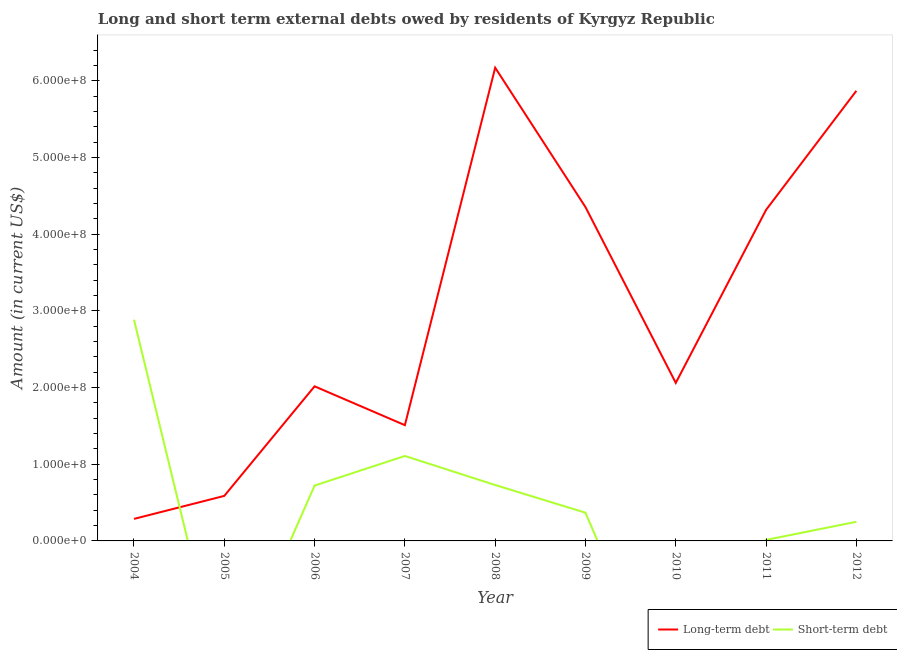Is the number of lines equal to the number of legend labels?
Make the answer very short. No. What is the long-term debts owed by residents in 2010?
Provide a succinct answer. 2.06e+08. Across all years, what is the maximum short-term debts owed by residents?
Give a very brief answer. 2.89e+08. Across all years, what is the minimum long-term debts owed by residents?
Offer a very short reply. 2.87e+07. What is the total long-term debts owed by residents in the graph?
Keep it short and to the point. 2.72e+09. What is the difference between the long-term debts owed by residents in 2008 and that in 2009?
Make the answer very short. 1.82e+08. What is the difference between the short-term debts owed by residents in 2011 and the long-term debts owed by residents in 2005?
Your answer should be compact. -5.74e+07. What is the average short-term debts owed by residents per year?
Keep it short and to the point. 6.75e+07. In the year 2009, what is the difference between the short-term debts owed by residents and long-term debts owed by residents?
Your answer should be compact. -3.99e+08. What is the ratio of the long-term debts owed by residents in 2004 to that in 2006?
Your answer should be compact. 0.14. Is the difference between the long-term debts owed by residents in 2006 and 2008 greater than the difference between the short-term debts owed by residents in 2006 and 2008?
Offer a terse response. No. What is the difference between the highest and the second highest long-term debts owed by residents?
Your answer should be compact. 3.01e+07. What is the difference between the highest and the lowest short-term debts owed by residents?
Keep it short and to the point. 2.89e+08. Is the sum of the long-term debts owed by residents in 2008 and 2012 greater than the maximum short-term debts owed by residents across all years?
Provide a succinct answer. Yes. Does the short-term debts owed by residents monotonically increase over the years?
Provide a short and direct response. No. How many lines are there?
Keep it short and to the point. 2. Are the values on the major ticks of Y-axis written in scientific E-notation?
Keep it short and to the point. Yes. Does the graph contain any zero values?
Make the answer very short. Yes. How many legend labels are there?
Offer a very short reply. 2. How are the legend labels stacked?
Keep it short and to the point. Horizontal. What is the title of the graph?
Ensure brevity in your answer.  Long and short term external debts owed by residents of Kyrgyz Republic. What is the Amount (in current US$) of Long-term debt in 2004?
Your response must be concise. 2.87e+07. What is the Amount (in current US$) in Short-term debt in 2004?
Your answer should be compact. 2.89e+08. What is the Amount (in current US$) in Long-term debt in 2005?
Keep it short and to the point. 5.87e+07. What is the Amount (in current US$) in Short-term debt in 2005?
Make the answer very short. 0. What is the Amount (in current US$) in Long-term debt in 2006?
Ensure brevity in your answer.  2.02e+08. What is the Amount (in current US$) of Short-term debt in 2006?
Your answer should be compact. 7.22e+07. What is the Amount (in current US$) of Long-term debt in 2007?
Your answer should be very brief. 1.51e+08. What is the Amount (in current US$) of Short-term debt in 2007?
Offer a terse response. 1.11e+08. What is the Amount (in current US$) of Long-term debt in 2008?
Provide a succinct answer. 6.17e+08. What is the Amount (in current US$) of Short-term debt in 2008?
Your answer should be compact. 7.29e+07. What is the Amount (in current US$) of Long-term debt in 2009?
Ensure brevity in your answer.  4.35e+08. What is the Amount (in current US$) in Short-term debt in 2009?
Offer a terse response. 3.68e+07. What is the Amount (in current US$) in Long-term debt in 2010?
Offer a very short reply. 2.06e+08. What is the Amount (in current US$) in Long-term debt in 2011?
Offer a terse response. 4.32e+08. What is the Amount (in current US$) of Short-term debt in 2011?
Make the answer very short. 1.36e+06. What is the Amount (in current US$) of Long-term debt in 2012?
Your response must be concise. 5.87e+08. What is the Amount (in current US$) in Short-term debt in 2012?
Make the answer very short. 2.49e+07. Across all years, what is the maximum Amount (in current US$) of Long-term debt?
Your answer should be compact. 6.17e+08. Across all years, what is the maximum Amount (in current US$) in Short-term debt?
Keep it short and to the point. 2.89e+08. Across all years, what is the minimum Amount (in current US$) of Long-term debt?
Your response must be concise. 2.87e+07. Across all years, what is the minimum Amount (in current US$) in Short-term debt?
Offer a terse response. 0. What is the total Amount (in current US$) in Long-term debt in the graph?
Your answer should be very brief. 2.72e+09. What is the total Amount (in current US$) of Short-term debt in the graph?
Your answer should be very brief. 6.07e+08. What is the difference between the Amount (in current US$) in Long-term debt in 2004 and that in 2005?
Give a very brief answer. -3.00e+07. What is the difference between the Amount (in current US$) in Long-term debt in 2004 and that in 2006?
Offer a very short reply. -1.73e+08. What is the difference between the Amount (in current US$) in Short-term debt in 2004 and that in 2006?
Provide a short and direct response. 2.16e+08. What is the difference between the Amount (in current US$) in Long-term debt in 2004 and that in 2007?
Your response must be concise. -1.22e+08. What is the difference between the Amount (in current US$) of Short-term debt in 2004 and that in 2007?
Your response must be concise. 1.78e+08. What is the difference between the Amount (in current US$) of Long-term debt in 2004 and that in 2008?
Ensure brevity in your answer.  -5.88e+08. What is the difference between the Amount (in current US$) of Short-term debt in 2004 and that in 2008?
Provide a succinct answer. 2.16e+08. What is the difference between the Amount (in current US$) in Long-term debt in 2004 and that in 2009?
Ensure brevity in your answer.  -4.07e+08. What is the difference between the Amount (in current US$) in Short-term debt in 2004 and that in 2009?
Your answer should be compact. 2.52e+08. What is the difference between the Amount (in current US$) in Long-term debt in 2004 and that in 2010?
Provide a short and direct response. -1.77e+08. What is the difference between the Amount (in current US$) in Long-term debt in 2004 and that in 2011?
Your answer should be very brief. -4.03e+08. What is the difference between the Amount (in current US$) in Short-term debt in 2004 and that in 2011?
Offer a terse response. 2.87e+08. What is the difference between the Amount (in current US$) in Long-term debt in 2004 and that in 2012?
Provide a succinct answer. -5.58e+08. What is the difference between the Amount (in current US$) of Short-term debt in 2004 and that in 2012?
Keep it short and to the point. 2.64e+08. What is the difference between the Amount (in current US$) in Long-term debt in 2005 and that in 2006?
Your answer should be very brief. -1.43e+08. What is the difference between the Amount (in current US$) of Long-term debt in 2005 and that in 2007?
Offer a terse response. -9.23e+07. What is the difference between the Amount (in current US$) of Long-term debt in 2005 and that in 2008?
Keep it short and to the point. -5.58e+08. What is the difference between the Amount (in current US$) in Long-term debt in 2005 and that in 2009?
Give a very brief answer. -3.77e+08. What is the difference between the Amount (in current US$) in Long-term debt in 2005 and that in 2010?
Offer a very short reply. -1.47e+08. What is the difference between the Amount (in current US$) in Long-term debt in 2005 and that in 2011?
Provide a short and direct response. -3.73e+08. What is the difference between the Amount (in current US$) in Long-term debt in 2005 and that in 2012?
Offer a very short reply. -5.28e+08. What is the difference between the Amount (in current US$) of Long-term debt in 2006 and that in 2007?
Provide a short and direct response. 5.06e+07. What is the difference between the Amount (in current US$) of Short-term debt in 2006 and that in 2007?
Give a very brief answer. -3.86e+07. What is the difference between the Amount (in current US$) of Long-term debt in 2006 and that in 2008?
Your answer should be very brief. -4.16e+08. What is the difference between the Amount (in current US$) in Short-term debt in 2006 and that in 2008?
Your answer should be compact. -7.16e+05. What is the difference between the Amount (in current US$) in Long-term debt in 2006 and that in 2009?
Your answer should be compact. -2.34e+08. What is the difference between the Amount (in current US$) of Short-term debt in 2006 and that in 2009?
Make the answer very short. 3.54e+07. What is the difference between the Amount (in current US$) of Long-term debt in 2006 and that in 2010?
Ensure brevity in your answer.  -4.47e+06. What is the difference between the Amount (in current US$) of Long-term debt in 2006 and that in 2011?
Give a very brief answer. -2.30e+08. What is the difference between the Amount (in current US$) in Short-term debt in 2006 and that in 2011?
Keep it short and to the point. 7.08e+07. What is the difference between the Amount (in current US$) in Long-term debt in 2006 and that in 2012?
Provide a succinct answer. -3.85e+08. What is the difference between the Amount (in current US$) in Short-term debt in 2006 and that in 2012?
Make the answer very short. 4.72e+07. What is the difference between the Amount (in current US$) in Long-term debt in 2007 and that in 2008?
Your answer should be very brief. -4.66e+08. What is the difference between the Amount (in current US$) of Short-term debt in 2007 and that in 2008?
Offer a terse response. 3.79e+07. What is the difference between the Amount (in current US$) of Long-term debt in 2007 and that in 2009?
Provide a short and direct response. -2.84e+08. What is the difference between the Amount (in current US$) in Short-term debt in 2007 and that in 2009?
Provide a short and direct response. 7.40e+07. What is the difference between the Amount (in current US$) in Long-term debt in 2007 and that in 2010?
Provide a short and direct response. -5.51e+07. What is the difference between the Amount (in current US$) of Long-term debt in 2007 and that in 2011?
Provide a succinct answer. -2.81e+08. What is the difference between the Amount (in current US$) in Short-term debt in 2007 and that in 2011?
Offer a terse response. 1.09e+08. What is the difference between the Amount (in current US$) in Long-term debt in 2007 and that in 2012?
Your answer should be very brief. -4.36e+08. What is the difference between the Amount (in current US$) in Short-term debt in 2007 and that in 2012?
Ensure brevity in your answer.  8.59e+07. What is the difference between the Amount (in current US$) in Long-term debt in 2008 and that in 2009?
Your answer should be compact. 1.82e+08. What is the difference between the Amount (in current US$) of Short-term debt in 2008 and that in 2009?
Offer a terse response. 3.61e+07. What is the difference between the Amount (in current US$) in Long-term debt in 2008 and that in 2010?
Give a very brief answer. 4.11e+08. What is the difference between the Amount (in current US$) in Long-term debt in 2008 and that in 2011?
Give a very brief answer. 1.85e+08. What is the difference between the Amount (in current US$) of Short-term debt in 2008 and that in 2011?
Keep it short and to the point. 7.15e+07. What is the difference between the Amount (in current US$) of Long-term debt in 2008 and that in 2012?
Keep it short and to the point. 3.01e+07. What is the difference between the Amount (in current US$) in Short-term debt in 2008 and that in 2012?
Offer a very short reply. 4.80e+07. What is the difference between the Amount (in current US$) in Long-term debt in 2009 and that in 2010?
Offer a very short reply. 2.29e+08. What is the difference between the Amount (in current US$) of Long-term debt in 2009 and that in 2011?
Offer a very short reply. 3.60e+06. What is the difference between the Amount (in current US$) of Short-term debt in 2009 and that in 2011?
Provide a succinct answer. 3.54e+07. What is the difference between the Amount (in current US$) of Long-term debt in 2009 and that in 2012?
Offer a very short reply. -1.52e+08. What is the difference between the Amount (in current US$) of Short-term debt in 2009 and that in 2012?
Offer a terse response. 1.19e+07. What is the difference between the Amount (in current US$) of Long-term debt in 2010 and that in 2011?
Make the answer very short. -2.26e+08. What is the difference between the Amount (in current US$) in Long-term debt in 2010 and that in 2012?
Your answer should be very brief. -3.81e+08. What is the difference between the Amount (in current US$) in Long-term debt in 2011 and that in 2012?
Give a very brief answer. -1.55e+08. What is the difference between the Amount (in current US$) of Short-term debt in 2011 and that in 2012?
Ensure brevity in your answer.  -2.36e+07. What is the difference between the Amount (in current US$) of Long-term debt in 2004 and the Amount (in current US$) of Short-term debt in 2006?
Provide a succinct answer. -4.35e+07. What is the difference between the Amount (in current US$) in Long-term debt in 2004 and the Amount (in current US$) in Short-term debt in 2007?
Offer a very short reply. -8.21e+07. What is the difference between the Amount (in current US$) in Long-term debt in 2004 and the Amount (in current US$) in Short-term debt in 2008?
Your answer should be compact. -4.42e+07. What is the difference between the Amount (in current US$) in Long-term debt in 2004 and the Amount (in current US$) in Short-term debt in 2009?
Keep it short and to the point. -8.07e+06. What is the difference between the Amount (in current US$) in Long-term debt in 2004 and the Amount (in current US$) in Short-term debt in 2011?
Offer a terse response. 2.74e+07. What is the difference between the Amount (in current US$) in Long-term debt in 2004 and the Amount (in current US$) in Short-term debt in 2012?
Ensure brevity in your answer.  3.79e+06. What is the difference between the Amount (in current US$) of Long-term debt in 2005 and the Amount (in current US$) of Short-term debt in 2006?
Provide a short and direct response. -1.35e+07. What is the difference between the Amount (in current US$) in Long-term debt in 2005 and the Amount (in current US$) in Short-term debt in 2007?
Offer a terse response. -5.21e+07. What is the difference between the Amount (in current US$) in Long-term debt in 2005 and the Amount (in current US$) in Short-term debt in 2008?
Offer a terse response. -1.42e+07. What is the difference between the Amount (in current US$) in Long-term debt in 2005 and the Amount (in current US$) in Short-term debt in 2009?
Offer a very short reply. 2.19e+07. What is the difference between the Amount (in current US$) in Long-term debt in 2005 and the Amount (in current US$) in Short-term debt in 2011?
Your answer should be very brief. 5.74e+07. What is the difference between the Amount (in current US$) in Long-term debt in 2005 and the Amount (in current US$) in Short-term debt in 2012?
Provide a succinct answer. 3.38e+07. What is the difference between the Amount (in current US$) of Long-term debt in 2006 and the Amount (in current US$) of Short-term debt in 2007?
Make the answer very short. 9.08e+07. What is the difference between the Amount (in current US$) of Long-term debt in 2006 and the Amount (in current US$) of Short-term debt in 2008?
Offer a terse response. 1.29e+08. What is the difference between the Amount (in current US$) of Long-term debt in 2006 and the Amount (in current US$) of Short-term debt in 2009?
Your answer should be compact. 1.65e+08. What is the difference between the Amount (in current US$) of Long-term debt in 2006 and the Amount (in current US$) of Short-term debt in 2011?
Provide a short and direct response. 2.00e+08. What is the difference between the Amount (in current US$) of Long-term debt in 2006 and the Amount (in current US$) of Short-term debt in 2012?
Your answer should be very brief. 1.77e+08. What is the difference between the Amount (in current US$) of Long-term debt in 2007 and the Amount (in current US$) of Short-term debt in 2008?
Offer a terse response. 7.81e+07. What is the difference between the Amount (in current US$) in Long-term debt in 2007 and the Amount (in current US$) in Short-term debt in 2009?
Give a very brief answer. 1.14e+08. What is the difference between the Amount (in current US$) of Long-term debt in 2007 and the Amount (in current US$) of Short-term debt in 2011?
Your response must be concise. 1.50e+08. What is the difference between the Amount (in current US$) in Long-term debt in 2007 and the Amount (in current US$) in Short-term debt in 2012?
Keep it short and to the point. 1.26e+08. What is the difference between the Amount (in current US$) in Long-term debt in 2008 and the Amount (in current US$) in Short-term debt in 2009?
Provide a short and direct response. 5.80e+08. What is the difference between the Amount (in current US$) of Long-term debt in 2008 and the Amount (in current US$) of Short-term debt in 2011?
Give a very brief answer. 6.16e+08. What is the difference between the Amount (in current US$) in Long-term debt in 2008 and the Amount (in current US$) in Short-term debt in 2012?
Your response must be concise. 5.92e+08. What is the difference between the Amount (in current US$) in Long-term debt in 2009 and the Amount (in current US$) in Short-term debt in 2011?
Your answer should be compact. 4.34e+08. What is the difference between the Amount (in current US$) in Long-term debt in 2009 and the Amount (in current US$) in Short-term debt in 2012?
Your answer should be compact. 4.10e+08. What is the difference between the Amount (in current US$) in Long-term debt in 2010 and the Amount (in current US$) in Short-term debt in 2011?
Your answer should be very brief. 2.05e+08. What is the difference between the Amount (in current US$) of Long-term debt in 2010 and the Amount (in current US$) of Short-term debt in 2012?
Ensure brevity in your answer.  1.81e+08. What is the difference between the Amount (in current US$) of Long-term debt in 2011 and the Amount (in current US$) of Short-term debt in 2012?
Provide a short and direct response. 4.07e+08. What is the average Amount (in current US$) in Long-term debt per year?
Make the answer very short. 3.02e+08. What is the average Amount (in current US$) of Short-term debt per year?
Provide a short and direct response. 6.75e+07. In the year 2004, what is the difference between the Amount (in current US$) of Long-term debt and Amount (in current US$) of Short-term debt?
Keep it short and to the point. -2.60e+08. In the year 2006, what is the difference between the Amount (in current US$) of Long-term debt and Amount (in current US$) of Short-term debt?
Provide a short and direct response. 1.29e+08. In the year 2007, what is the difference between the Amount (in current US$) in Long-term debt and Amount (in current US$) in Short-term debt?
Your response must be concise. 4.02e+07. In the year 2008, what is the difference between the Amount (in current US$) in Long-term debt and Amount (in current US$) in Short-term debt?
Your answer should be compact. 5.44e+08. In the year 2009, what is the difference between the Amount (in current US$) in Long-term debt and Amount (in current US$) in Short-term debt?
Provide a succinct answer. 3.99e+08. In the year 2011, what is the difference between the Amount (in current US$) of Long-term debt and Amount (in current US$) of Short-term debt?
Offer a very short reply. 4.30e+08. In the year 2012, what is the difference between the Amount (in current US$) in Long-term debt and Amount (in current US$) in Short-term debt?
Give a very brief answer. 5.62e+08. What is the ratio of the Amount (in current US$) in Long-term debt in 2004 to that in 2005?
Your answer should be very brief. 0.49. What is the ratio of the Amount (in current US$) of Long-term debt in 2004 to that in 2006?
Provide a succinct answer. 0.14. What is the ratio of the Amount (in current US$) of Short-term debt in 2004 to that in 2006?
Keep it short and to the point. 4. What is the ratio of the Amount (in current US$) of Long-term debt in 2004 to that in 2007?
Ensure brevity in your answer.  0.19. What is the ratio of the Amount (in current US$) of Short-term debt in 2004 to that in 2007?
Offer a terse response. 2.6. What is the ratio of the Amount (in current US$) of Long-term debt in 2004 to that in 2008?
Ensure brevity in your answer.  0.05. What is the ratio of the Amount (in current US$) in Short-term debt in 2004 to that in 2008?
Provide a succinct answer. 3.96. What is the ratio of the Amount (in current US$) in Long-term debt in 2004 to that in 2009?
Your response must be concise. 0.07. What is the ratio of the Amount (in current US$) of Short-term debt in 2004 to that in 2009?
Ensure brevity in your answer.  7.84. What is the ratio of the Amount (in current US$) in Long-term debt in 2004 to that in 2010?
Make the answer very short. 0.14. What is the ratio of the Amount (in current US$) of Long-term debt in 2004 to that in 2011?
Provide a succinct answer. 0.07. What is the ratio of the Amount (in current US$) of Short-term debt in 2004 to that in 2011?
Provide a succinct answer. 212.31. What is the ratio of the Amount (in current US$) in Long-term debt in 2004 to that in 2012?
Offer a very short reply. 0.05. What is the ratio of the Amount (in current US$) in Short-term debt in 2004 to that in 2012?
Give a very brief answer. 11.58. What is the ratio of the Amount (in current US$) in Long-term debt in 2005 to that in 2006?
Keep it short and to the point. 0.29. What is the ratio of the Amount (in current US$) in Long-term debt in 2005 to that in 2007?
Provide a succinct answer. 0.39. What is the ratio of the Amount (in current US$) of Long-term debt in 2005 to that in 2008?
Provide a succinct answer. 0.1. What is the ratio of the Amount (in current US$) of Long-term debt in 2005 to that in 2009?
Offer a very short reply. 0.13. What is the ratio of the Amount (in current US$) of Long-term debt in 2005 to that in 2010?
Your response must be concise. 0.28. What is the ratio of the Amount (in current US$) of Long-term debt in 2005 to that in 2011?
Keep it short and to the point. 0.14. What is the ratio of the Amount (in current US$) of Long-term debt in 2006 to that in 2007?
Your answer should be very brief. 1.34. What is the ratio of the Amount (in current US$) in Short-term debt in 2006 to that in 2007?
Give a very brief answer. 0.65. What is the ratio of the Amount (in current US$) of Long-term debt in 2006 to that in 2008?
Provide a succinct answer. 0.33. What is the ratio of the Amount (in current US$) in Short-term debt in 2006 to that in 2008?
Ensure brevity in your answer.  0.99. What is the ratio of the Amount (in current US$) of Long-term debt in 2006 to that in 2009?
Make the answer very short. 0.46. What is the ratio of the Amount (in current US$) in Short-term debt in 2006 to that in 2009?
Provide a short and direct response. 1.96. What is the ratio of the Amount (in current US$) of Long-term debt in 2006 to that in 2010?
Offer a terse response. 0.98. What is the ratio of the Amount (in current US$) in Long-term debt in 2006 to that in 2011?
Offer a very short reply. 0.47. What is the ratio of the Amount (in current US$) in Short-term debt in 2006 to that in 2011?
Ensure brevity in your answer.  53.11. What is the ratio of the Amount (in current US$) in Long-term debt in 2006 to that in 2012?
Your answer should be very brief. 0.34. What is the ratio of the Amount (in current US$) in Short-term debt in 2006 to that in 2012?
Ensure brevity in your answer.  2.9. What is the ratio of the Amount (in current US$) of Long-term debt in 2007 to that in 2008?
Ensure brevity in your answer.  0.24. What is the ratio of the Amount (in current US$) in Short-term debt in 2007 to that in 2008?
Provide a succinct answer. 1.52. What is the ratio of the Amount (in current US$) in Long-term debt in 2007 to that in 2009?
Offer a terse response. 0.35. What is the ratio of the Amount (in current US$) of Short-term debt in 2007 to that in 2009?
Your answer should be compact. 3.01. What is the ratio of the Amount (in current US$) of Long-term debt in 2007 to that in 2010?
Your answer should be very brief. 0.73. What is the ratio of the Amount (in current US$) in Long-term debt in 2007 to that in 2011?
Ensure brevity in your answer.  0.35. What is the ratio of the Amount (in current US$) in Short-term debt in 2007 to that in 2011?
Provide a short and direct response. 81.52. What is the ratio of the Amount (in current US$) in Long-term debt in 2007 to that in 2012?
Provide a short and direct response. 0.26. What is the ratio of the Amount (in current US$) in Short-term debt in 2007 to that in 2012?
Make the answer very short. 4.44. What is the ratio of the Amount (in current US$) in Long-term debt in 2008 to that in 2009?
Ensure brevity in your answer.  1.42. What is the ratio of the Amount (in current US$) in Short-term debt in 2008 to that in 2009?
Provide a succinct answer. 1.98. What is the ratio of the Amount (in current US$) of Long-term debt in 2008 to that in 2010?
Ensure brevity in your answer.  2.99. What is the ratio of the Amount (in current US$) of Long-term debt in 2008 to that in 2011?
Give a very brief answer. 1.43. What is the ratio of the Amount (in current US$) of Short-term debt in 2008 to that in 2011?
Your response must be concise. 53.64. What is the ratio of the Amount (in current US$) in Long-term debt in 2008 to that in 2012?
Give a very brief answer. 1.05. What is the ratio of the Amount (in current US$) of Short-term debt in 2008 to that in 2012?
Your answer should be very brief. 2.92. What is the ratio of the Amount (in current US$) in Long-term debt in 2009 to that in 2010?
Provide a short and direct response. 2.11. What is the ratio of the Amount (in current US$) of Long-term debt in 2009 to that in 2011?
Provide a succinct answer. 1.01. What is the ratio of the Amount (in current US$) in Short-term debt in 2009 to that in 2011?
Provide a succinct answer. 27.07. What is the ratio of the Amount (in current US$) of Long-term debt in 2009 to that in 2012?
Ensure brevity in your answer.  0.74. What is the ratio of the Amount (in current US$) in Short-term debt in 2009 to that in 2012?
Give a very brief answer. 1.48. What is the ratio of the Amount (in current US$) of Long-term debt in 2010 to that in 2011?
Provide a short and direct response. 0.48. What is the ratio of the Amount (in current US$) of Long-term debt in 2010 to that in 2012?
Give a very brief answer. 0.35. What is the ratio of the Amount (in current US$) of Long-term debt in 2011 to that in 2012?
Keep it short and to the point. 0.74. What is the ratio of the Amount (in current US$) in Short-term debt in 2011 to that in 2012?
Offer a very short reply. 0.05. What is the difference between the highest and the second highest Amount (in current US$) in Long-term debt?
Give a very brief answer. 3.01e+07. What is the difference between the highest and the second highest Amount (in current US$) in Short-term debt?
Ensure brevity in your answer.  1.78e+08. What is the difference between the highest and the lowest Amount (in current US$) of Long-term debt?
Give a very brief answer. 5.88e+08. What is the difference between the highest and the lowest Amount (in current US$) in Short-term debt?
Keep it short and to the point. 2.89e+08. 